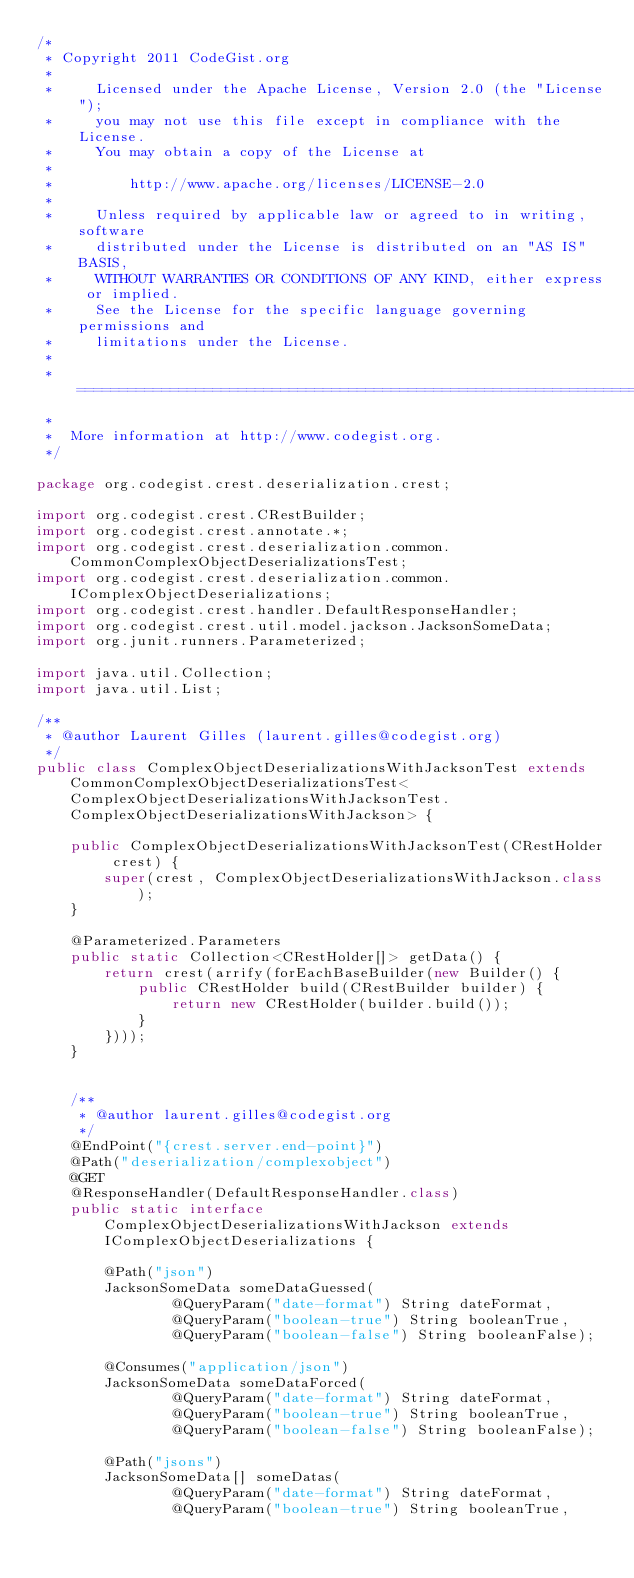<code> <loc_0><loc_0><loc_500><loc_500><_Java_>/*
 * Copyright 2011 CodeGist.org
 *
 *     Licensed under the Apache License, Version 2.0 (the "License");
 *     you may not use this file except in compliance with the License.
 *     You may obtain a copy of the License at
 *
 *         http://www.apache.org/licenses/LICENSE-2.0
 *
 *     Unless required by applicable law or agreed to in writing, software
 *     distributed under the License is distributed on an "AS IS" BASIS,
 *     WITHOUT WARRANTIES OR CONDITIONS OF ANY KIND, either express or implied.
 *     See the License for the specific language governing permissions and
 *     limitations under the License.
 *
 *  ===================================================================
 *
 *  More information at http://www.codegist.org.
 */

package org.codegist.crest.deserialization.crest;

import org.codegist.crest.CRestBuilder;
import org.codegist.crest.annotate.*;
import org.codegist.crest.deserialization.common.CommonComplexObjectDeserializationsTest;
import org.codegist.crest.deserialization.common.IComplexObjectDeserializations;
import org.codegist.crest.handler.DefaultResponseHandler;
import org.codegist.crest.util.model.jackson.JacksonSomeData;
import org.junit.runners.Parameterized;

import java.util.Collection;
import java.util.List;

/**
 * @author Laurent Gilles (laurent.gilles@codegist.org)
 */
public class ComplexObjectDeserializationsWithJacksonTest extends CommonComplexObjectDeserializationsTest<ComplexObjectDeserializationsWithJacksonTest.ComplexObjectDeserializationsWithJackson> {

    public ComplexObjectDeserializationsWithJacksonTest(CRestHolder crest) {
        super(crest, ComplexObjectDeserializationsWithJackson.class);
    }

    @Parameterized.Parameters
    public static Collection<CRestHolder[]> getData() {
        return crest(arrify(forEachBaseBuilder(new Builder() {
            public CRestHolder build(CRestBuilder builder) {
                return new CRestHolder(builder.build());
            }
        })));
    }


    /**
     * @author laurent.gilles@codegist.org
     */
    @EndPoint("{crest.server.end-point}")
    @Path("deserialization/complexobject")
    @GET
    @ResponseHandler(DefaultResponseHandler.class)
    public static interface ComplexObjectDeserializationsWithJackson extends IComplexObjectDeserializations {

        @Path("json")
        JacksonSomeData someDataGuessed(
                @QueryParam("date-format") String dateFormat,
                @QueryParam("boolean-true") String booleanTrue,
                @QueryParam("boolean-false") String booleanFalse);

        @Consumes("application/json")
        JacksonSomeData someDataForced(
                @QueryParam("date-format") String dateFormat,
                @QueryParam("boolean-true") String booleanTrue,
                @QueryParam("boolean-false") String booleanFalse);

        @Path("jsons")
        JacksonSomeData[] someDatas(
                @QueryParam("date-format") String dateFormat,
                @QueryParam("boolean-true") String booleanTrue,</code> 